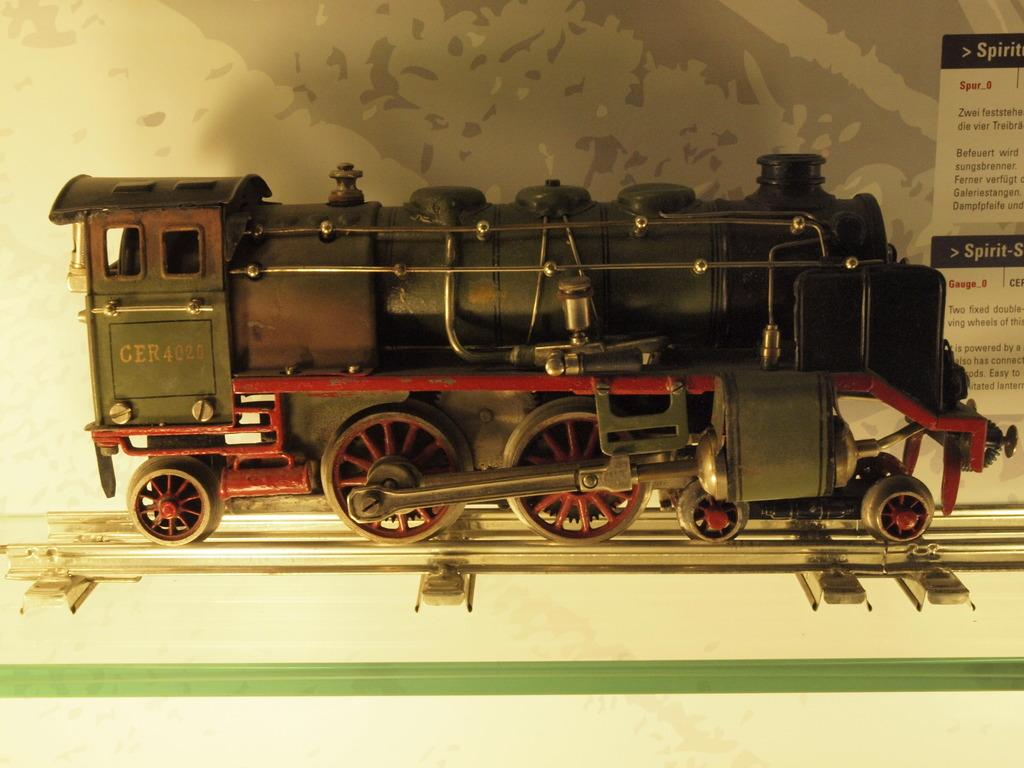What type of toy is in the image? There is a small black and red color train engine miniature toy in the image. Where is the toy placed? The toy is placed on a glass shelf. What other item can be seen in the image? There is a paper brochure in the image. How is the paper brochure positioned in relation to the toy? The paper brochure is beside the toy. What type of disease is affecting the train engine toy in the image? There is no indication of any disease affecting the train engine toy in the image. The toy appears to be in good condition and is not displaying any signs of illness or damage. 